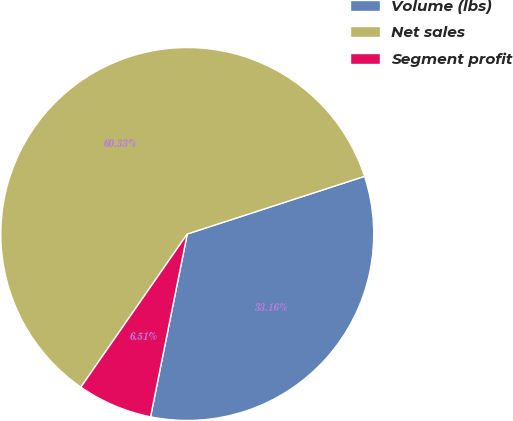Convert chart to OTSL. <chart><loc_0><loc_0><loc_500><loc_500><pie_chart><fcel>Volume (lbs)<fcel>Net sales<fcel>Segment profit<nl><fcel>33.16%<fcel>60.33%<fcel>6.51%<nl></chart> 